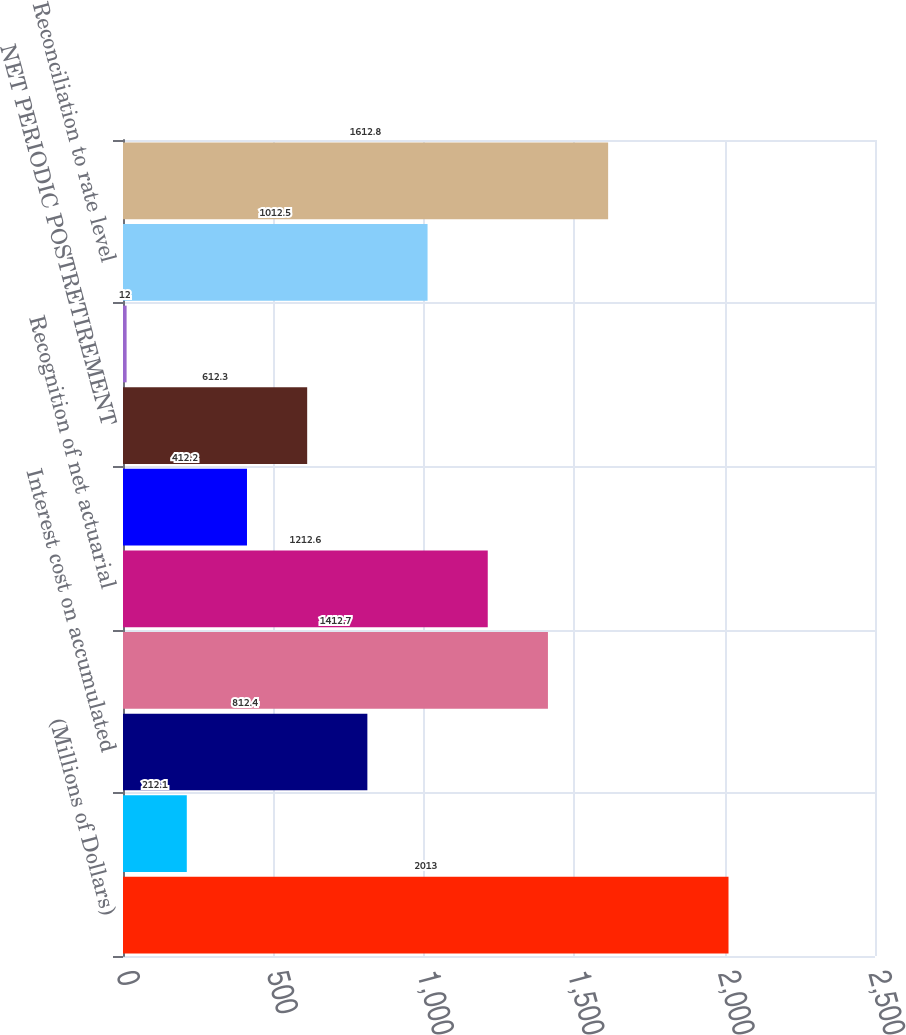Convert chart to OTSL. <chart><loc_0><loc_0><loc_500><loc_500><bar_chart><fcel>(Millions of Dollars)<fcel>Service cost<fcel>Interest cost on accumulated<fcel>Expected return on plan assets<fcel>Recognition of net actuarial<fcel>Recognition of prior service<fcel>NET PERIODIC POSTRETIREMENT<fcel>Cost capitalized<fcel>Reconciliation to rate level<fcel>Cost charged to operating<nl><fcel>2013<fcel>212.1<fcel>812.4<fcel>1412.7<fcel>1212.6<fcel>412.2<fcel>612.3<fcel>12<fcel>1012.5<fcel>1612.8<nl></chart> 